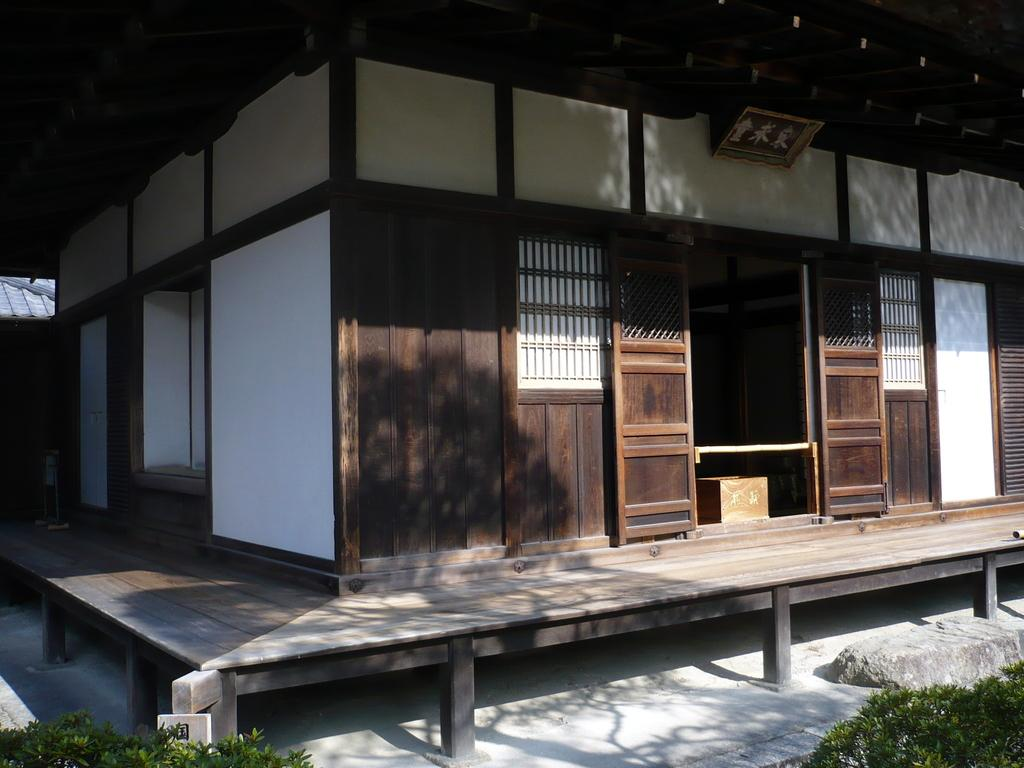What type of house is in the center of the image? There is a wooden house in the center of the image. What is covering the top of the house? The house has a roof. What surrounds the house in the image? There is a frame around the house. What can be seen at the bottom of the image? Plants are visible at the bottom of the image. What material is present in the image besides wood and plants? There is a stone in the image. What is the surface that the house is standing on? There is a floor in the image. What type of fowl can be seen gripping the stone in the image? There are no birds or any gripping action involving a stone in the image. 